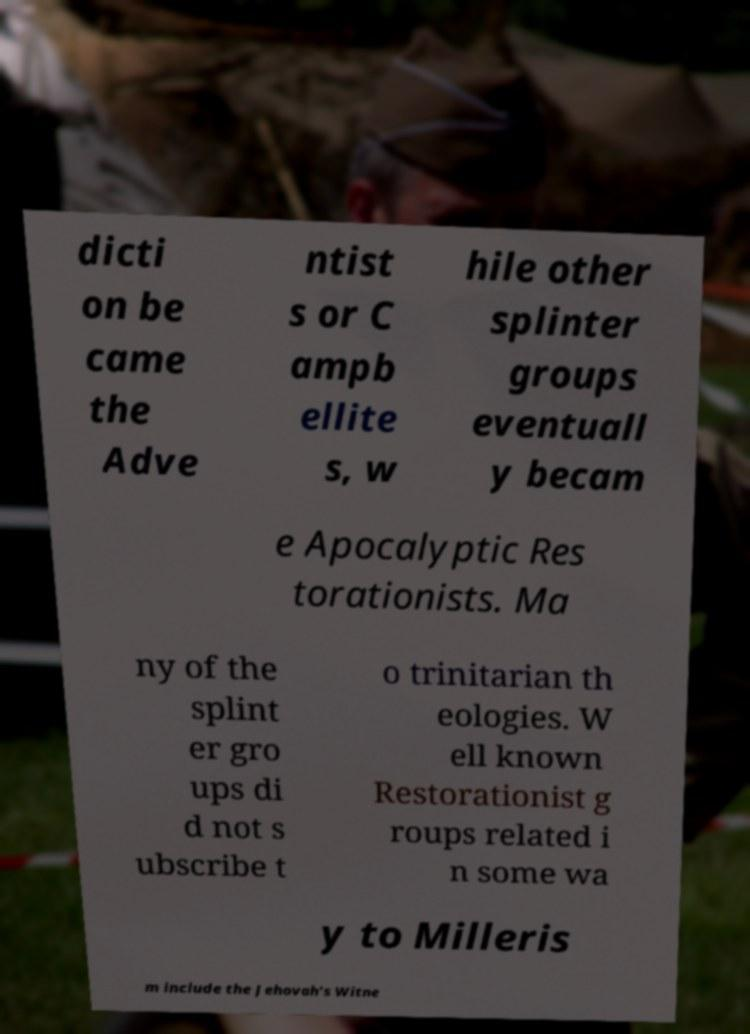For documentation purposes, I need the text within this image transcribed. Could you provide that? dicti on be came the Adve ntist s or C ampb ellite s, w hile other splinter groups eventuall y becam e Apocalyptic Res torationists. Ma ny of the splint er gro ups di d not s ubscribe t o trinitarian th eologies. W ell known Restorationist g roups related i n some wa y to Milleris m include the Jehovah's Witne 